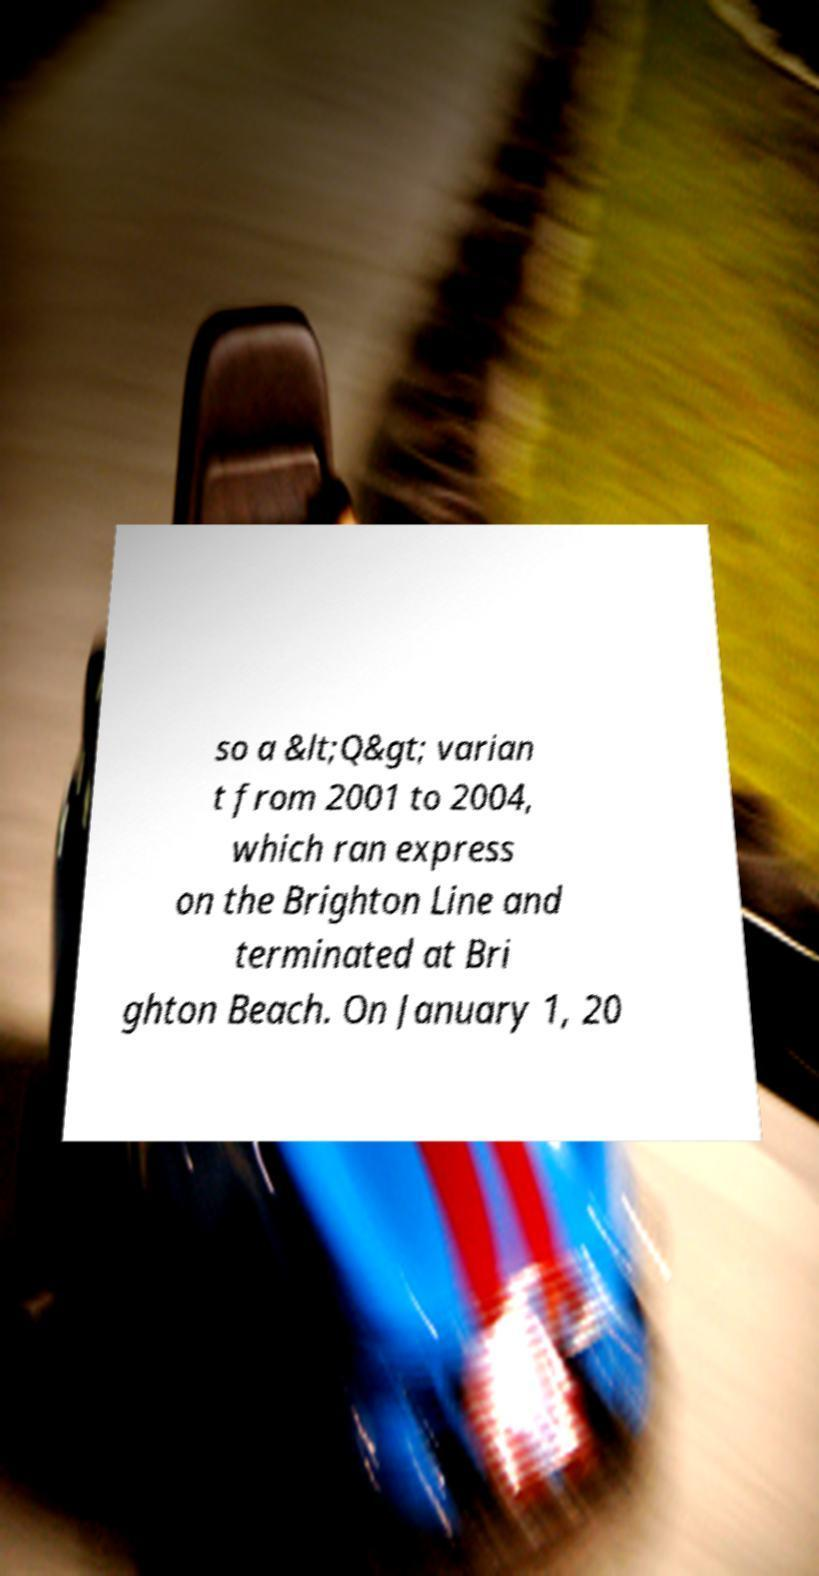I need the written content from this picture converted into text. Can you do that? so a &lt;Q&gt; varian t from 2001 to 2004, which ran express on the Brighton Line and terminated at Bri ghton Beach. On January 1, 20 